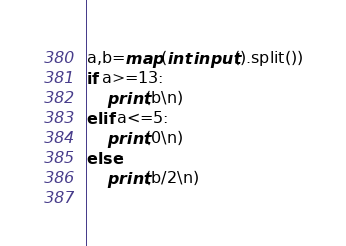Convert code to text. <code><loc_0><loc_0><loc_500><loc_500><_Python_>a,b=map(int input().split())
if a>=13:
    print(b\n)
elif a<=5:
    print(0\n)
else:
    print(b/2\n)
    </code> 